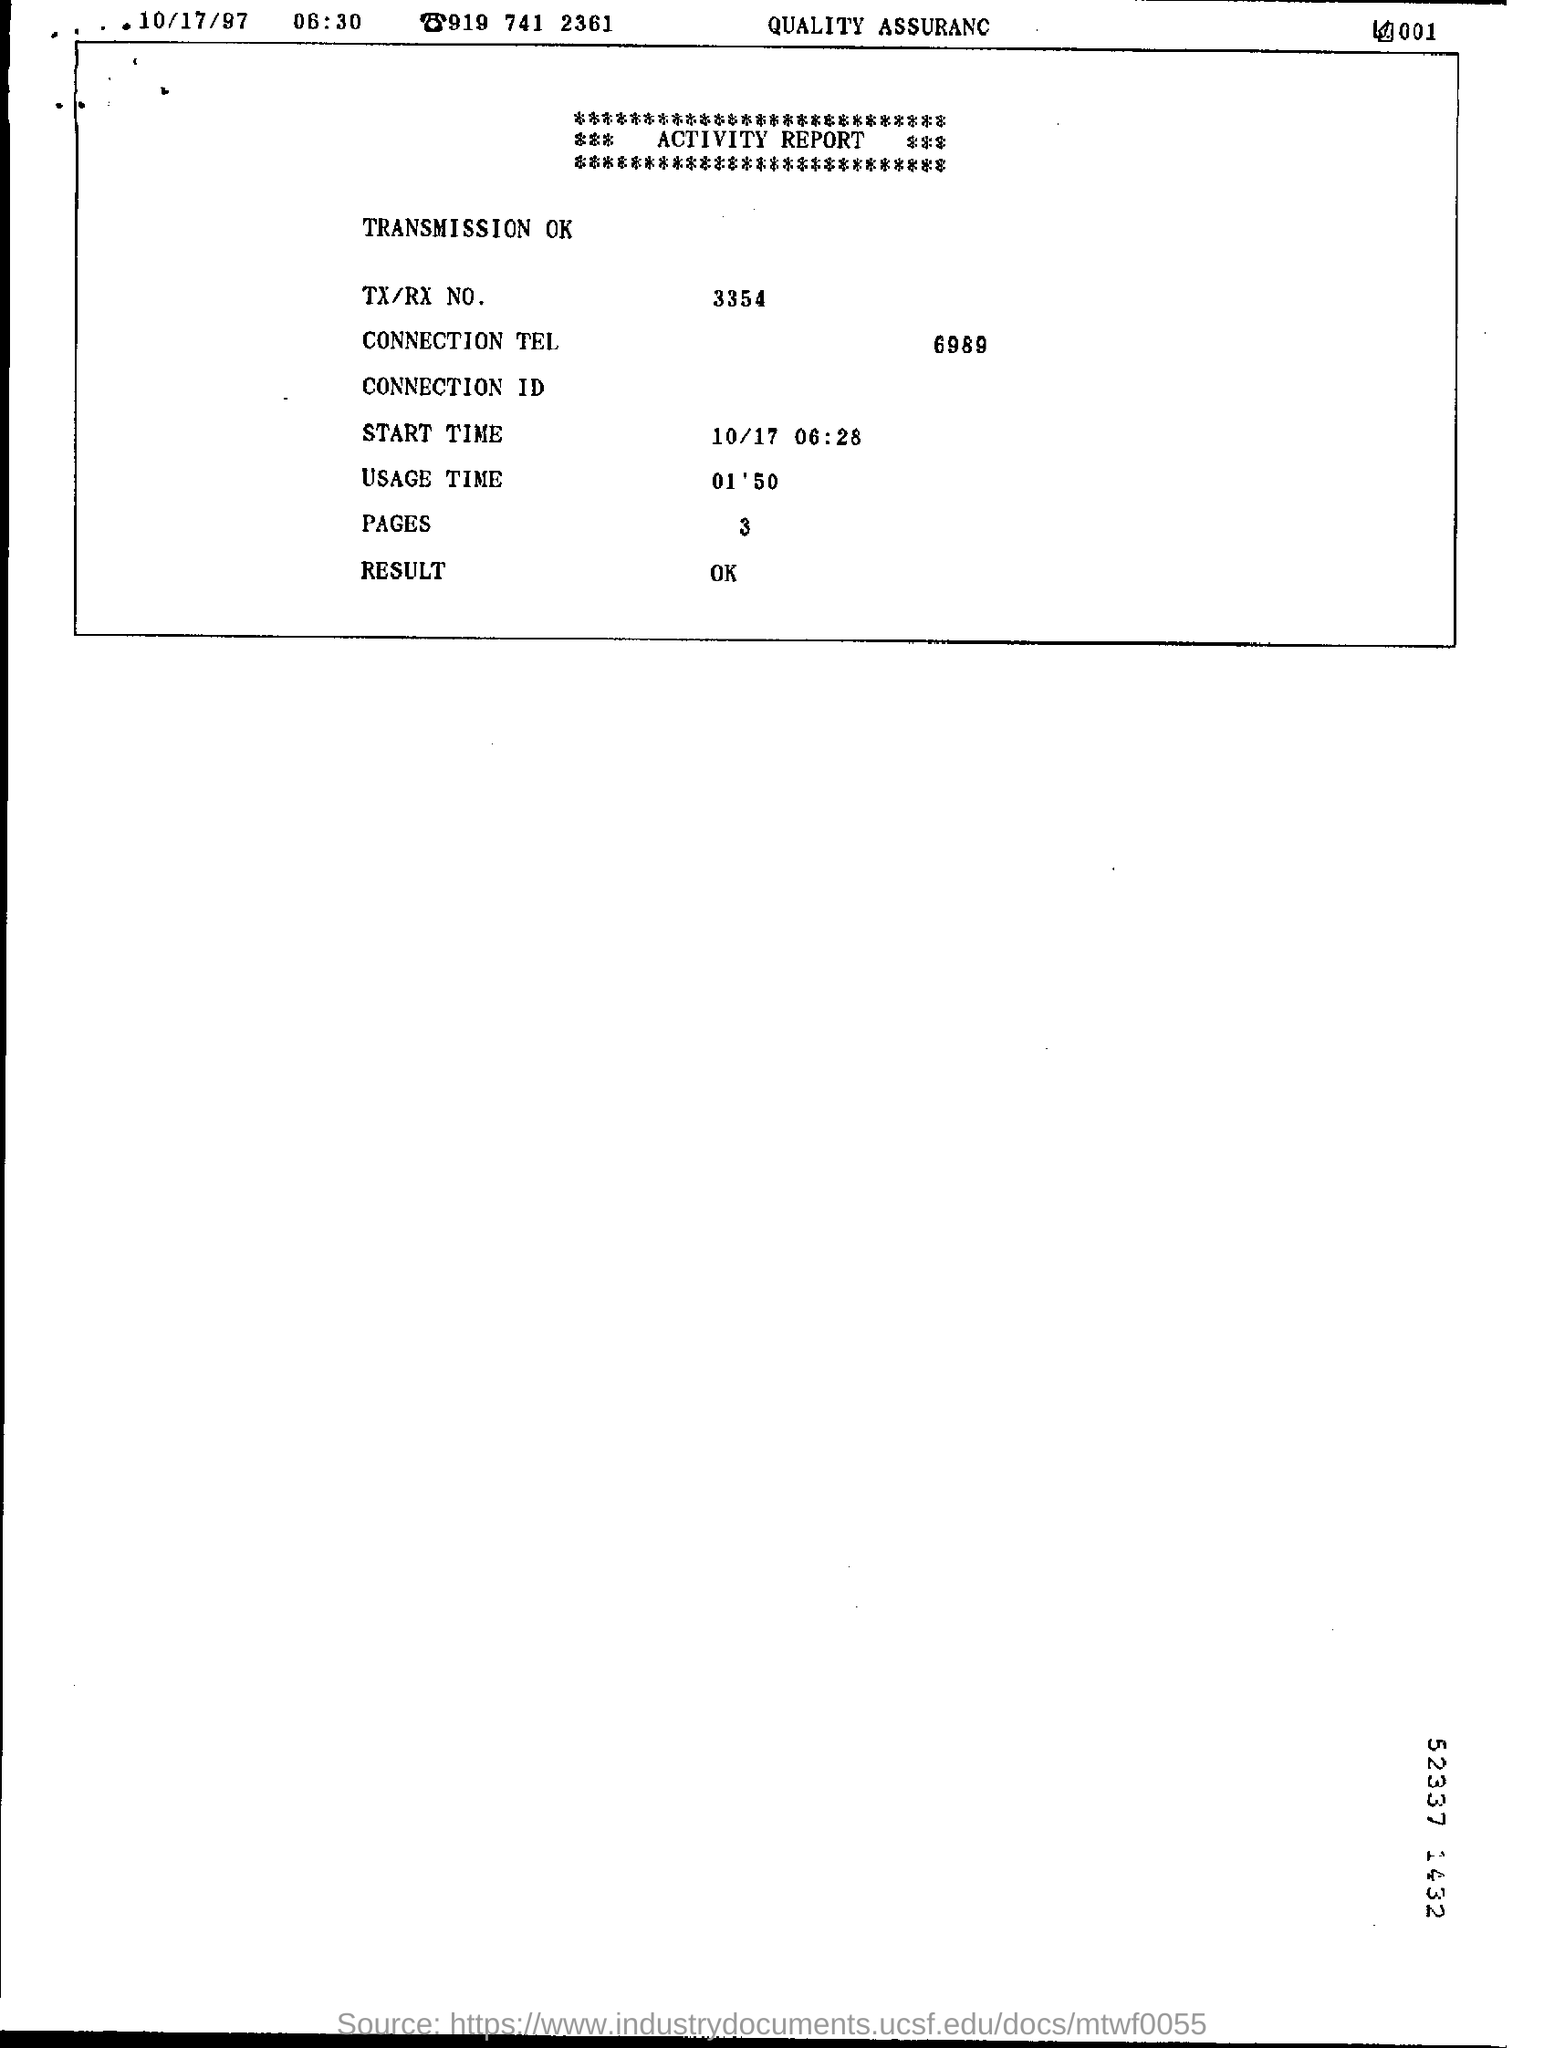Give some essential details in this illustration. What is the TX/RX number? It is 3354. The telephone number 6989... is a connection number. The result is OK. 